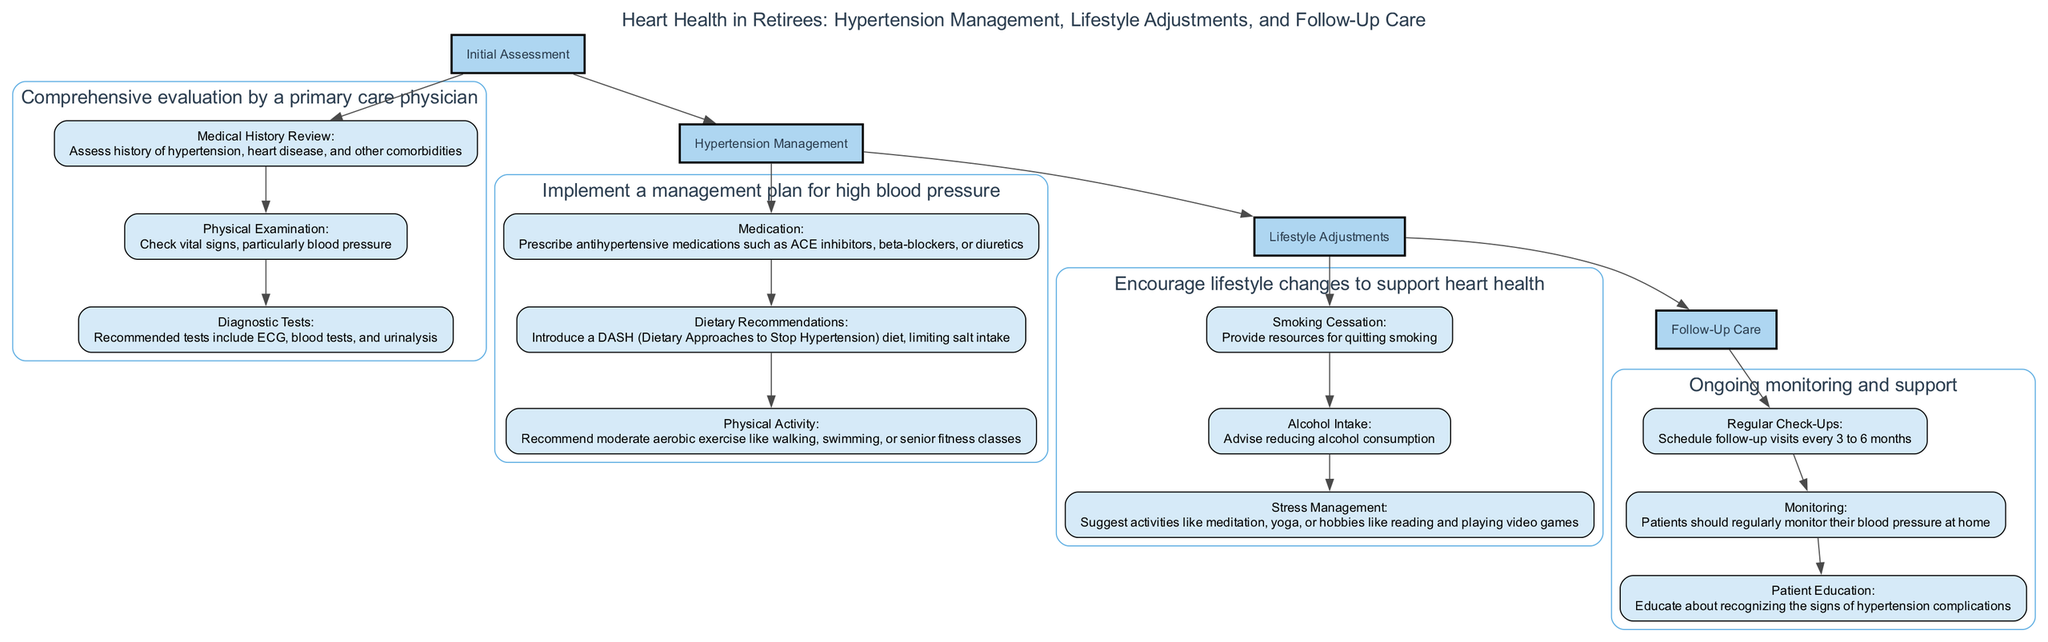What is the first step in the clinical pathway? The first step listed in the clinical pathway is "Initial Assessment."
Answer: Initial Assessment How many main steps are there in the clinical pathway? There are four main steps detailed in the diagram: Initial Assessment, Hypertension Management, Lifestyle Adjustments, and Follow-Up Care.
Answer: Four What type of exercise is recommended for managing hypertension? The recommended type of exercise is "moderate aerobic exercise."
Answer: Moderate aerobic exercise Which lifestyle change is suggested for reducing alcohol consumption? The diagram advises "reducing alcohol consumption" as a key lifestyle adjustment.
Answer: Reducing alcohol consumption What is the substep under Follow-Up Care that focuses on regular check-ups? The substep under Follow-Up Care related to regular check-ups is "Regular Check-Ups."
Answer: Regular Check-Ups How often should follow-up visits be scheduled according to the diagram? Follow-up visits should be scheduled "every 3 to 6 months" as per the pathway.
Answer: Every 3 to 6 months Which substep under Hypertension Management pertains to diet? The substep under Hypertension Management that pertains to diet is "Dietary Recommendations."
Answer: Dietary Recommendations What role do hobbies like reading and video games play in lifestyle adjustments? Hobbies like reading and playing video games are suggested for "Stress Management."
Answer: Stress Management What is the focus of the "Monitoring" substep in Follow-Up Care? The focus of the Monitoring substep is for patients to "regularly monitor their blood pressure at home."
Answer: Regularly monitor blood pressure at home 